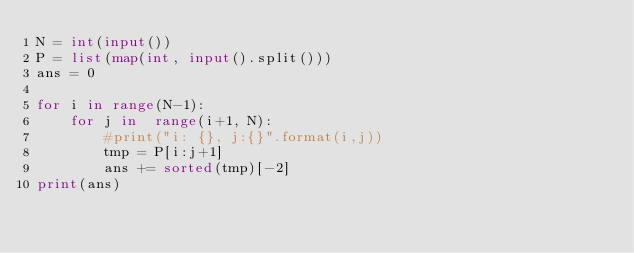Convert code to text. <code><loc_0><loc_0><loc_500><loc_500><_Python_>N = int(input())
P = list(map(int, input().split()))
ans = 0

for i in range(N-1):
	for j in  range(i+1, N):
		#print("i: {}, j:{}".format(i,j))
		tmp = P[i:j+1]
		ans += sorted(tmp)[-2]
print(ans)</code> 